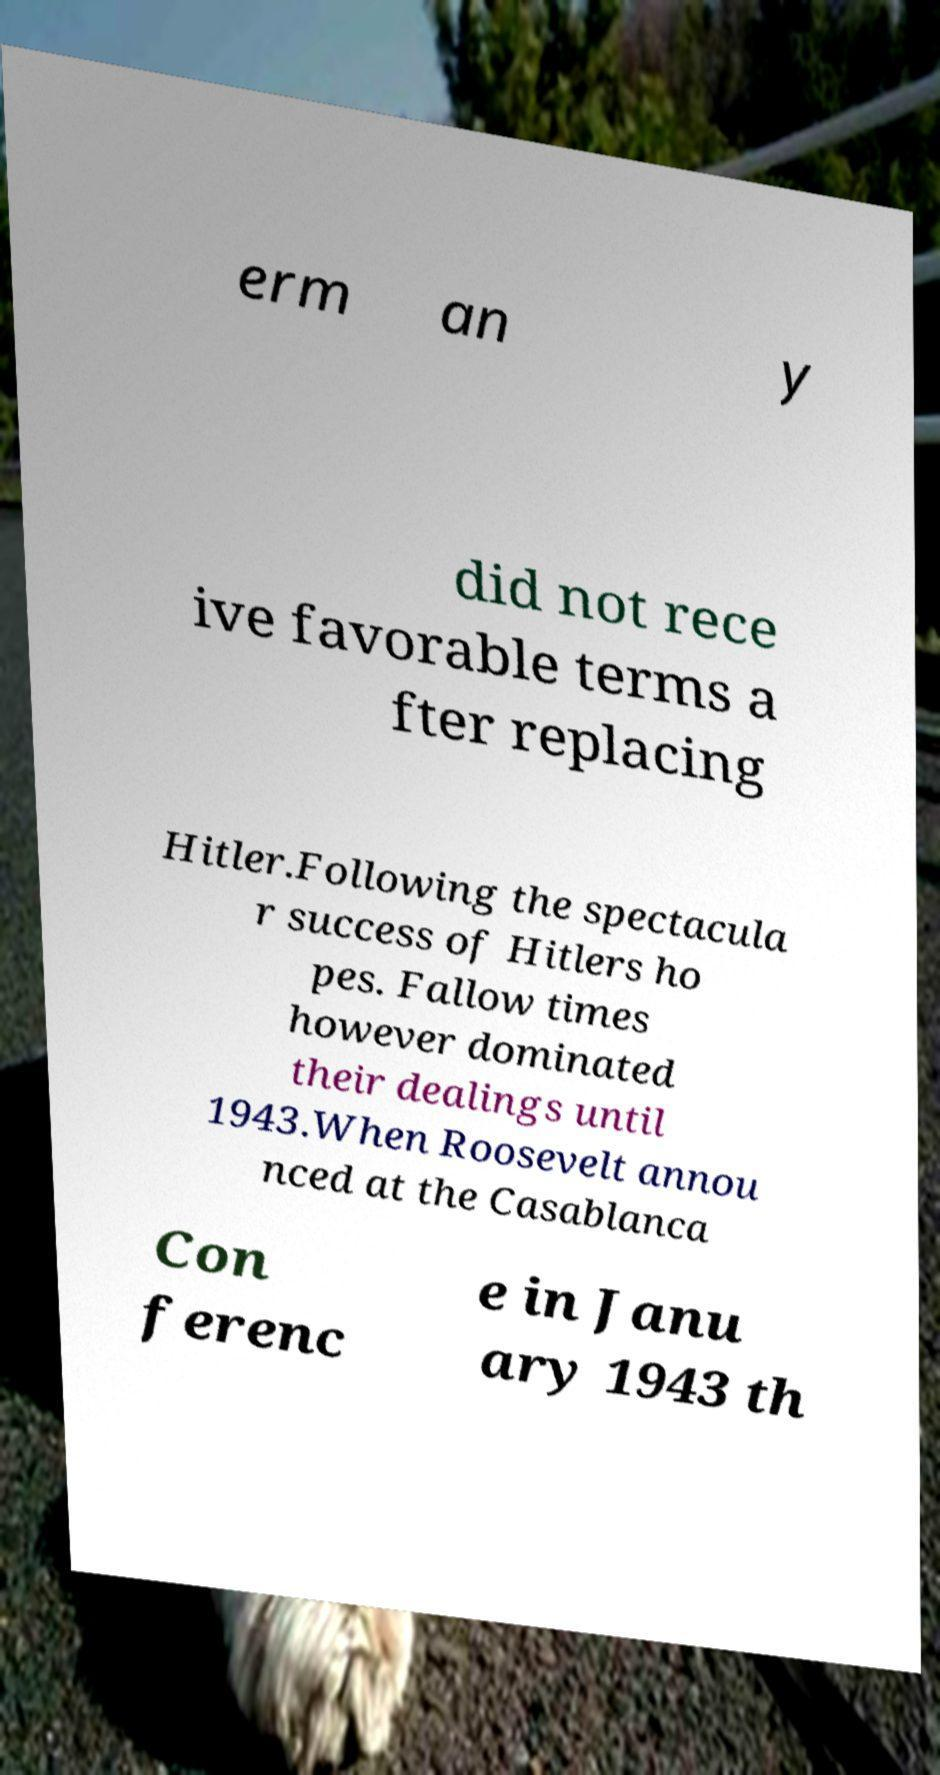What messages or text are displayed in this image? I need them in a readable, typed format. erm an y did not rece ive favorable terms a fter replacing Hitler.Following the spectacula r success of Hitlers ho pes. Fallow times however dominated their dealings until 1943.When Roosevelt annou nced at the Casablanca Con ferenc e in Janu ary 1943 th 